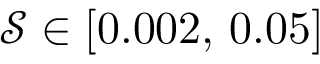<formula> <loc_0><loc_0><loc_500><loc_500>\mathcal { S } \in [ 0 . 0 0 2 , \, 0 . 0 5 ]</formula> 